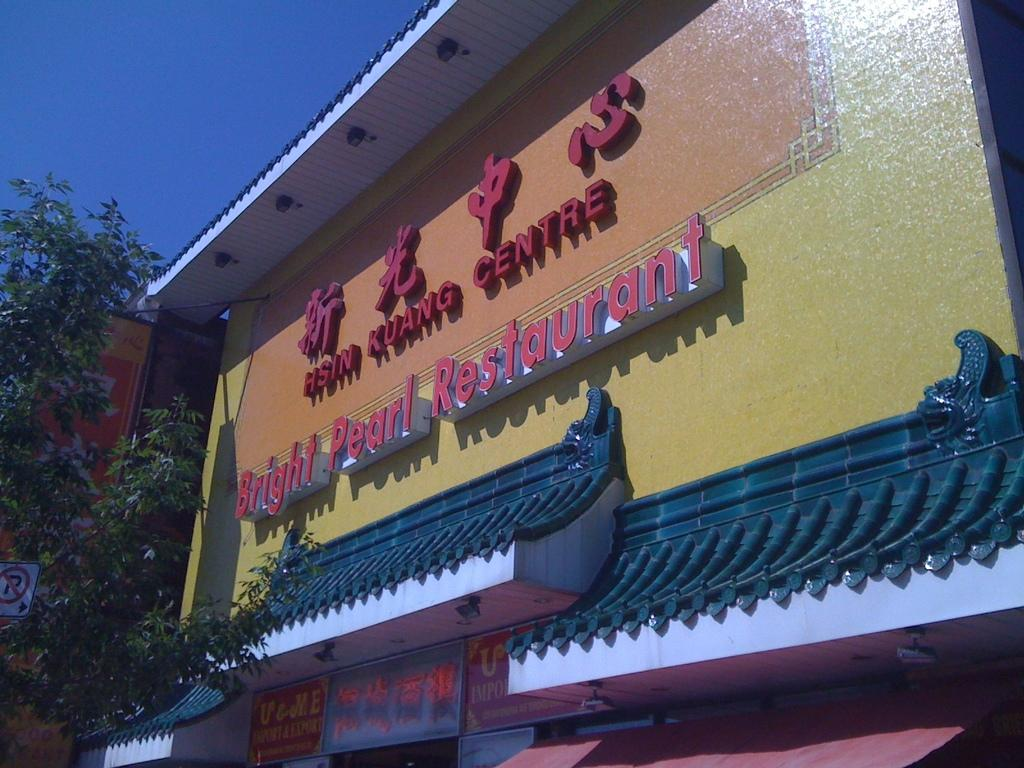Provide a one-sentence caption for the provided image. hsin kuang centre bright pearl restaurant building exterior. 